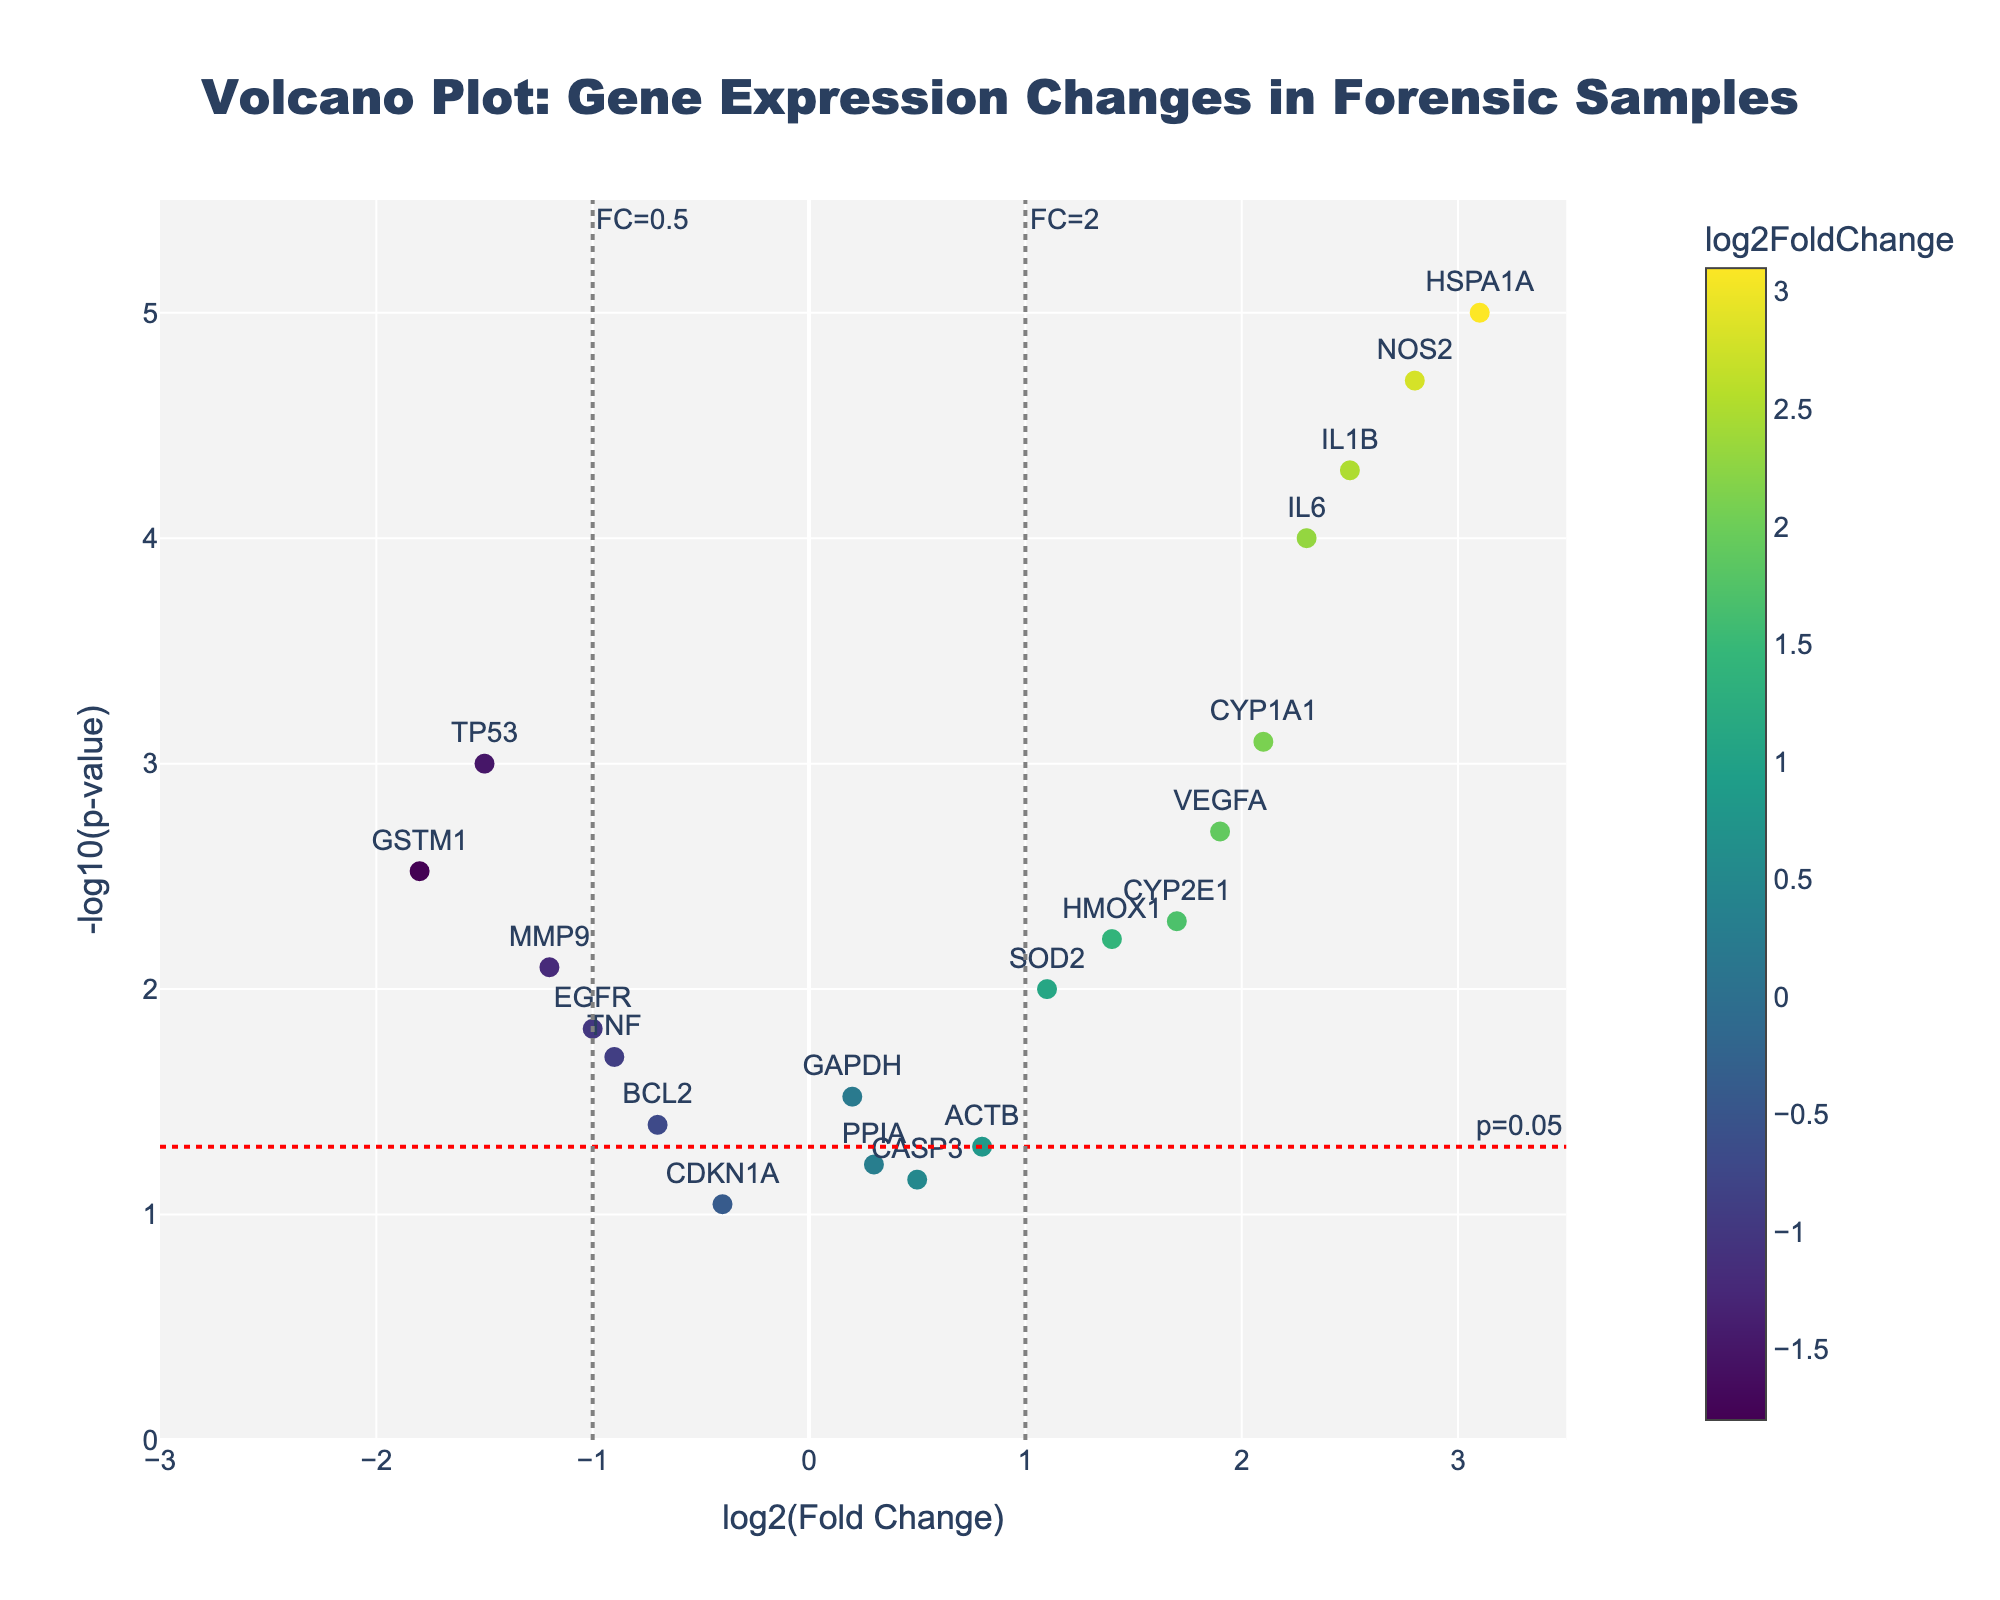What is the title of the figure? The title of the figure is typically displayed at the top. In this case, it reads "Volcano Plot: Gene Expression Changes in Forensic Samples".
Answer: Volcano Plot: Gene Expression Changes in Forensic Samples How many genes have a log2 fold change greater than 2? Look for points on the scatter plot where the log2(Fold Change) value is greater than 2. The genes IL6, HSPA1A, IL1B, NOS2, and CYP1A1 meet this criterion.
Answer: 5 Which gene has the highest -log10(p-value)? The highest -log10(p-value) is represented by the point at the top of the plot. From the hover text or visual inspection, HSPA1A has the highest -log10(p-value).
Answer: HSPA1A What is the log2FoldChange and p-value for IL6? Find the IL6 label on the plot. The hover text shows the log2(Fold Change) and p-value for IL6: log2FC = 2.3 and p-value = 0.0001.
Answer: log2FC = 2.3, p-value = 0.0001 Which genes are statistically significant and have a fold change greater than 2? Statistically significant genes are typically below the p=0.05 threshold, which is visualized as above the horizontal red line, with a log2FoldChange greater than 2. IL6, HSPA1A, IL1B, and NOS2 meet these criteria.
Answer: IL6, HSPA1A, IL1B, NOS2 How many genes are to the left of the fold change threshold at -1? Count the points to the left of the vertical line at x = -1. The genes TP53, GSTM1, and MMP9 meet this criterion.
Answer: 3 Compare GAPDH and TP53: which gene has a more significant p-value and what are their fold changes? Compare the position above the p=0.05 line and along the x-axis. TP53 has a more significant p-value as it is higher on the y-axis. The fold changes are as follows: GAPDH = 0.2, TP53 = -1.5.
Answer: TP53 has a more significant p-value; GAPDH log2FC = 0.2, TP53 log2FC = -1.5 Which gene would you say is the least statistically significant and what is its corresponding log2 fold change? The least statistically significant gene has the lowest -log10(p-value), near the bottom of the plot. CASP3 has the lowest -log10(p-value) just above the p=0.05 threshold. Its log2FoldChange is 0.5.
Answer: CASP3 with log2FC = 0.5 What is the range of the -log10(p-value) axis? The range of the -log10(p-value) axis extends from the bottom to the top of the plot. Visually, this range is from 0 to 5.5 as shown by the axis limits.
Answer: 0 to 5.5 Which gene has a negative log2 fold change but is still statistically significant? Focus on genes with negative log2FoldChange values (to the left of zero) but that are above the horizontal line for p=0.05. TP53, TNF, MMP9, GSTM1, and EGFR are statistically significant and have negative log2 fold changes.
Answer: TP53, TNF, MMP9, GSTM1, EGFR 